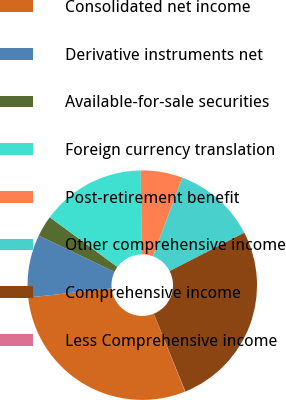<chart> <loc_0><loc_0><loc_500><loc_500><pie_chart><fcel>Consolidated net income<fcel>Derivative instruments net<fcel>Available-for-sale securities<fcel>Foreign currency translation<fcel>Post-retirement benefit<fcel>Other comprehensive income<fcel>Comprehensive income<fcel>Less Comprehensive income<nl><fcel>29.36%<fcel>8.83%<fcel>2.97%<fcel>14.7%<fcel>5.9%<fcel>11.77%<fcel>26.43%<fcel>0.04%<nl></chart> 